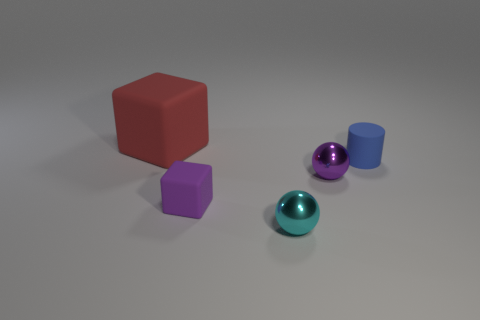There is a thing that is on the left side of the cube that is in front of the big rubber object; what is it made of?
Offer a terse response. Rubber. There is a tiny thing in front of the small matte cube; is its shape the same as the small purple metallic object?
Make the answer very short. Yes. There is a big block that is the same material as the blue cylinder; what is its color?
Your answer should be compact. Red. There is a thing in front of the purple matte block; what is it made of?
Ensure brevity in your answer.  Metal. Is the shape of the cyan thing the same as the small metallic thing right of the tiny cyan shiny ball?
Your answer should be very brief. Yes. What is the small object that is both on the left side of the tiny purple sphere and to the right of the small purple cube made of?
Offer a terse response. Metal. There is a cylinder that is the same size as the purple rubber block; what is its color?
Offer a terse response. Blue. Are the large cube and the small ball that is behind the cyan shiny sphere made of the same material?
Your answer should be compact. No. How many other objects are there of the same size as the red thing?
Offer a very short reply. 0. Are there any large red objects in front of the small thing that is on the right side of the ball that is to the right of the small cyan shiny ball?
Offer a very short reply. No. 